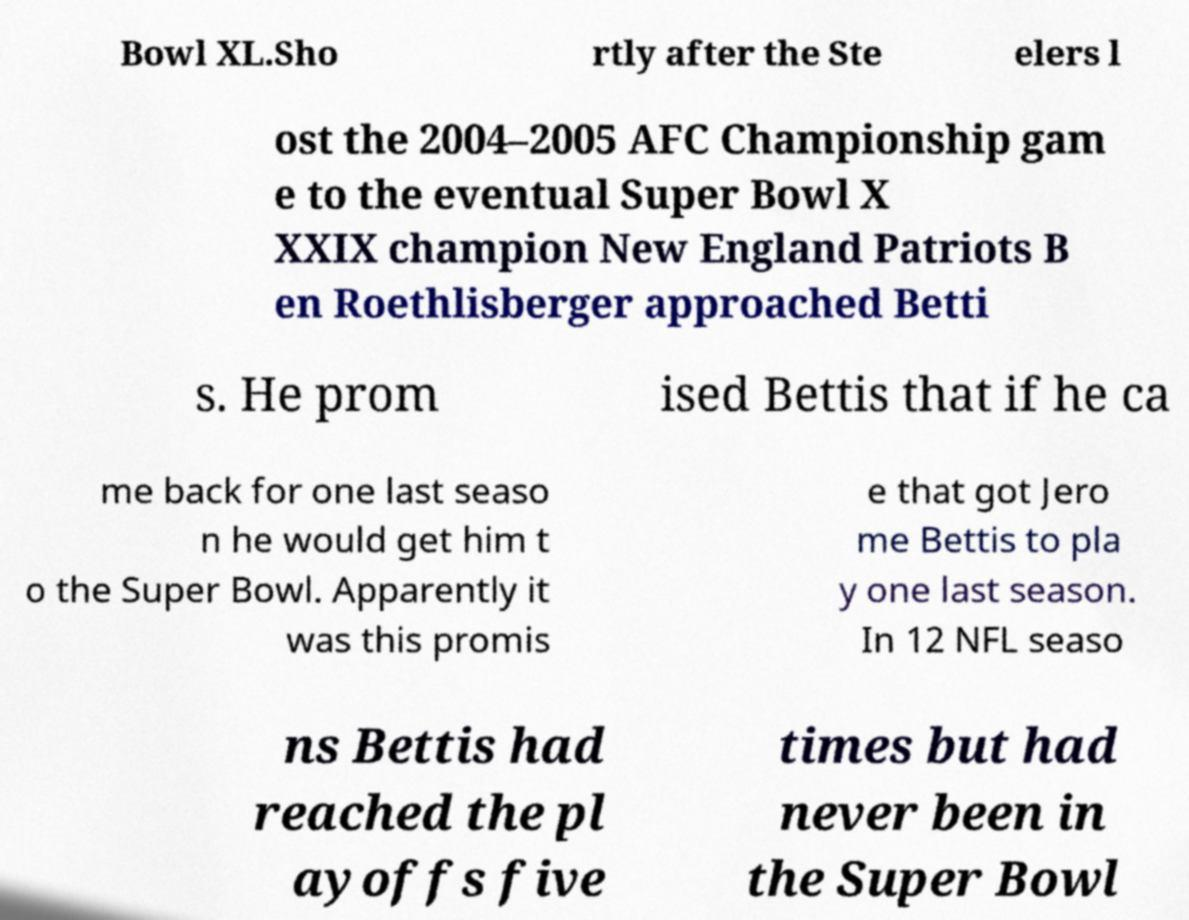There's text embedded in this image that I need extracted. Can you transcribe it verbatim? Bowl XL.Sho rtly after the Ste elers l ost the 2004–2005 AFC Championship gam e to the eventual Super Bowl X XXIX champion New England Patriots B en Roethlisberger approached Betti s. He prom ised Bettis that if he ca me back for one last seaso n he would get him t o the Super Bowl. Apparently it was this promis e that got Jero me Bettis to pla y one last season. In 12 NFL seaso ns Bettis had reached the pl ayoffs five times but had never been in the Super Bowl 